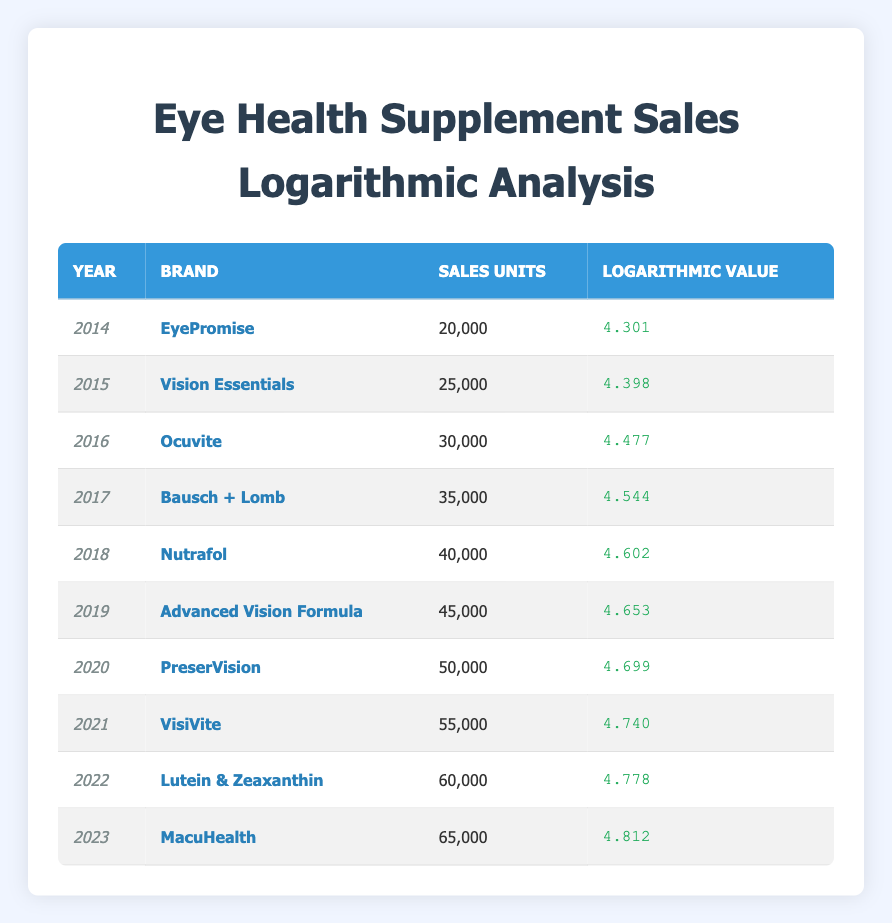What brand had the highest sales units in 2022? Looking at the table for the year 2022, the brand listed is "Lutein & Zeaxanthin" with sales units of 60,000. This is checked against other years, confirming that it is not surpassed in that specific year.
Answer: Lutein & Zeaxanthin What was the logarithmic value for sales in 2016? In the table, the year 2016 is associated with the brand "Ocuvite," which has a logarithmic value of 4.477.
Answer: 4.477 What is the total number of sales units from 2014 to 2023? To find the total, you need to sum the sales units from each year: 20,000 + 25,000 + 30,000 + 35,000 + 40,000 + 45,000 + 50,000 + 55,000 + 60,000 + 65,000 =  20,000 + 25,000 + 30,000 + 35,000 + 40,000 + 45,000 + 50,000 + 55,000 + 60,000 + 65,000 =  500,000.
Answer: 500,000 Did sales increase every year from 2014 to 2023? By reviewing the sales units from each year, we see a consistent increase: 20,000 (2014) to 65,000 (2023). Since every year has a higher value than the one prior, we confirm there were no decreases.
Answer: Yes What is the average logarithmic value from 2014 to 2023? To calculate the average, sum the logarithmic values from each year and divide by the number of years: (4.301 + 4.398 + 4.477 + 4.544 + 4.602 + 4.653 + 4.699 + 4.740 + 4.778 + 4.812) =  44.604. Then divide by 10 (the number of years): 44.604 / 10 = 4.4604.
Answer: 4.4604 Which brand saw the largest increase in sales from one year to the next? To find the largest increase, calculate the difference in sales units for each adjacent year: (25,000 - 20,000 = 5,000), (30,000 - 25,000 = 5,000), (35,000 - 30,000 = 5,000), (40,000 - 35,000 = 5,000), (45,000 - 40,000 = 5,000), (50,000 - 45,000 = 5,000), (55,000 - 50,000 = 5,000), (60,000 - 55,000 = 5,000), (65,000 - 60,000 = 5,000). All brands show the same increase of 5,000 across each year without any larger single year growth.
Answer: None What was the logarithmic value for the brand that had the lowest sales unit in the table? The brand with the lowest sales units listed in the table is "EyePromise" from 2014, which has a logarithmic value of 4.301.
Answer: 4.301 In which year was the brand 'PreserVision' sold? The table indicates that 'PreserVision' was sold in the year 2020, with corresponding sales units of 50,000.
Answer: 2020 